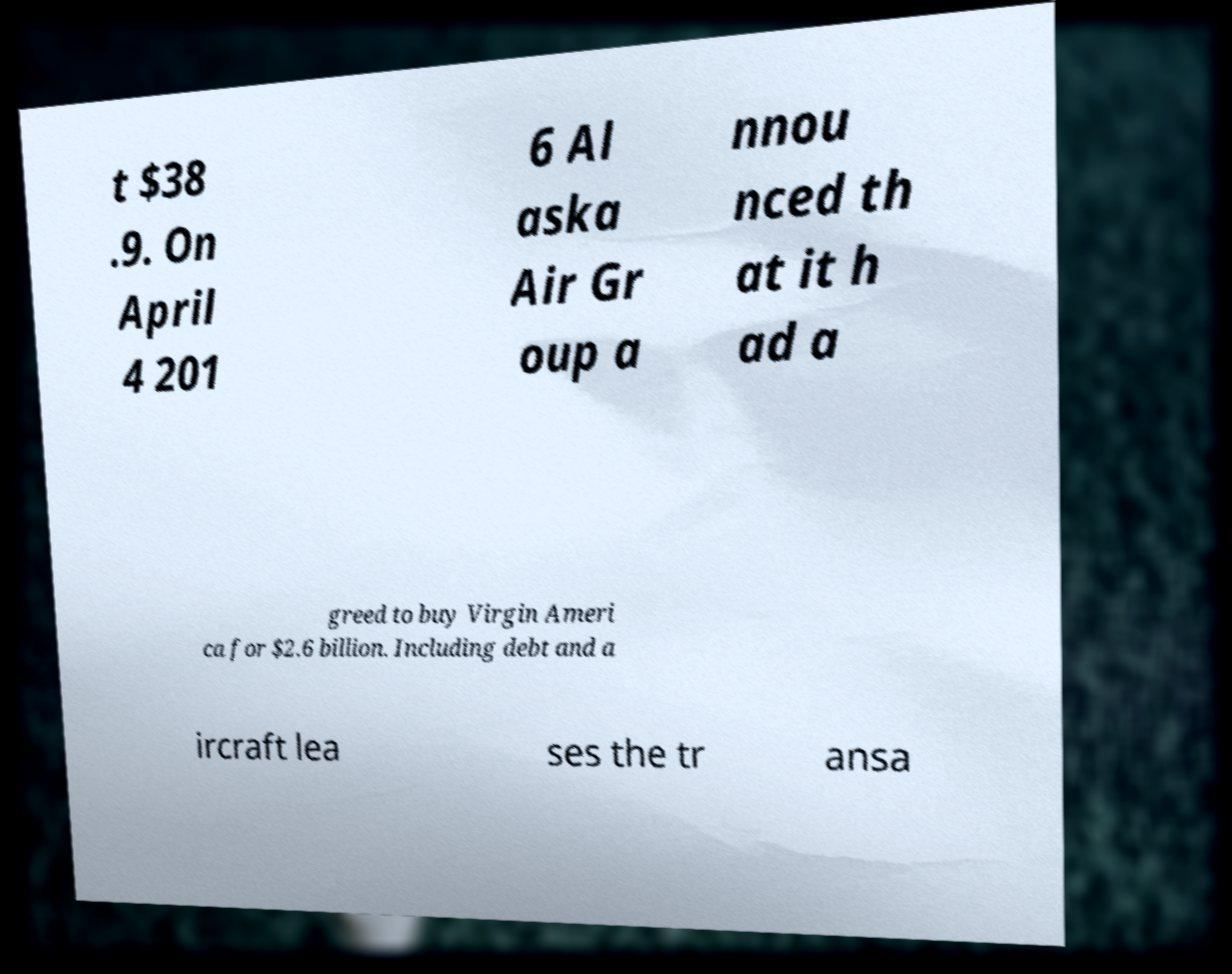For documentation purposes, I need the text within this image transcribed. Could you provide that? t $38 .9. On April 4 201 6 Al aska Air Gr oup a nnou nced th at it h ad a greed to buy Virgin Ameri ca for $2.6 billion. Including debt and a ircraft lea ses the tr ansa 